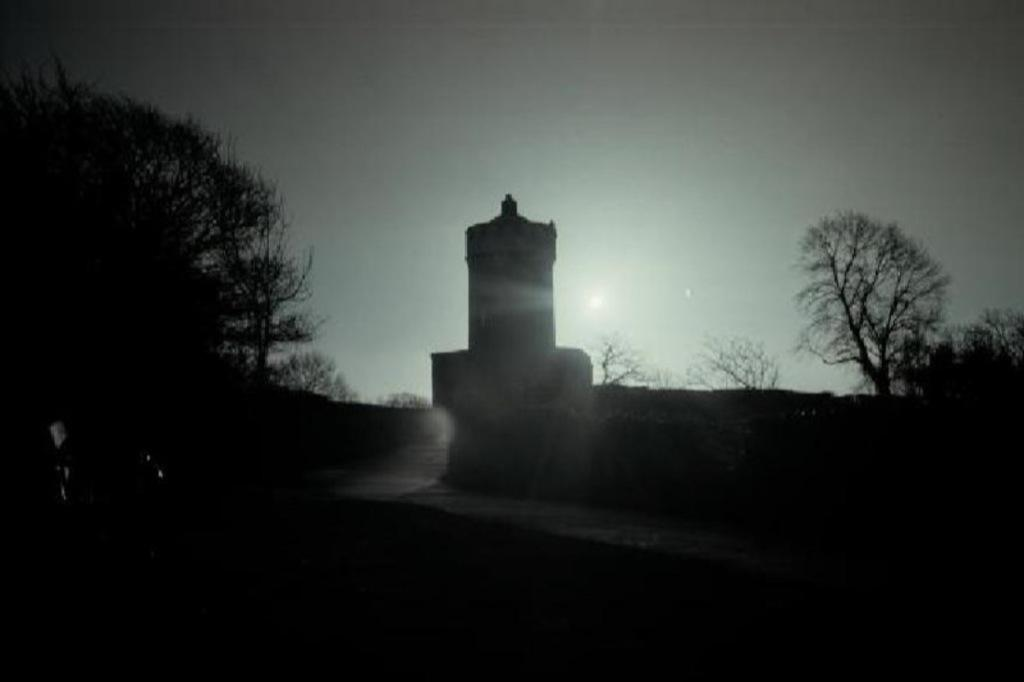What type of picture is in the image? The image contains a black and white picture. What natural elements can be seen in the picture? There are trees visible in the picture. What human activity is depicted in the picture? There is construction visible in the picture. What part of the natural environment is visible in the picture? The sky is visible in the picture. What celestial body can be seen in the sky? The sun is observable in the picture. What type of cake is being tasted by the ant in the image? There are no ants or cakes present in the image. 